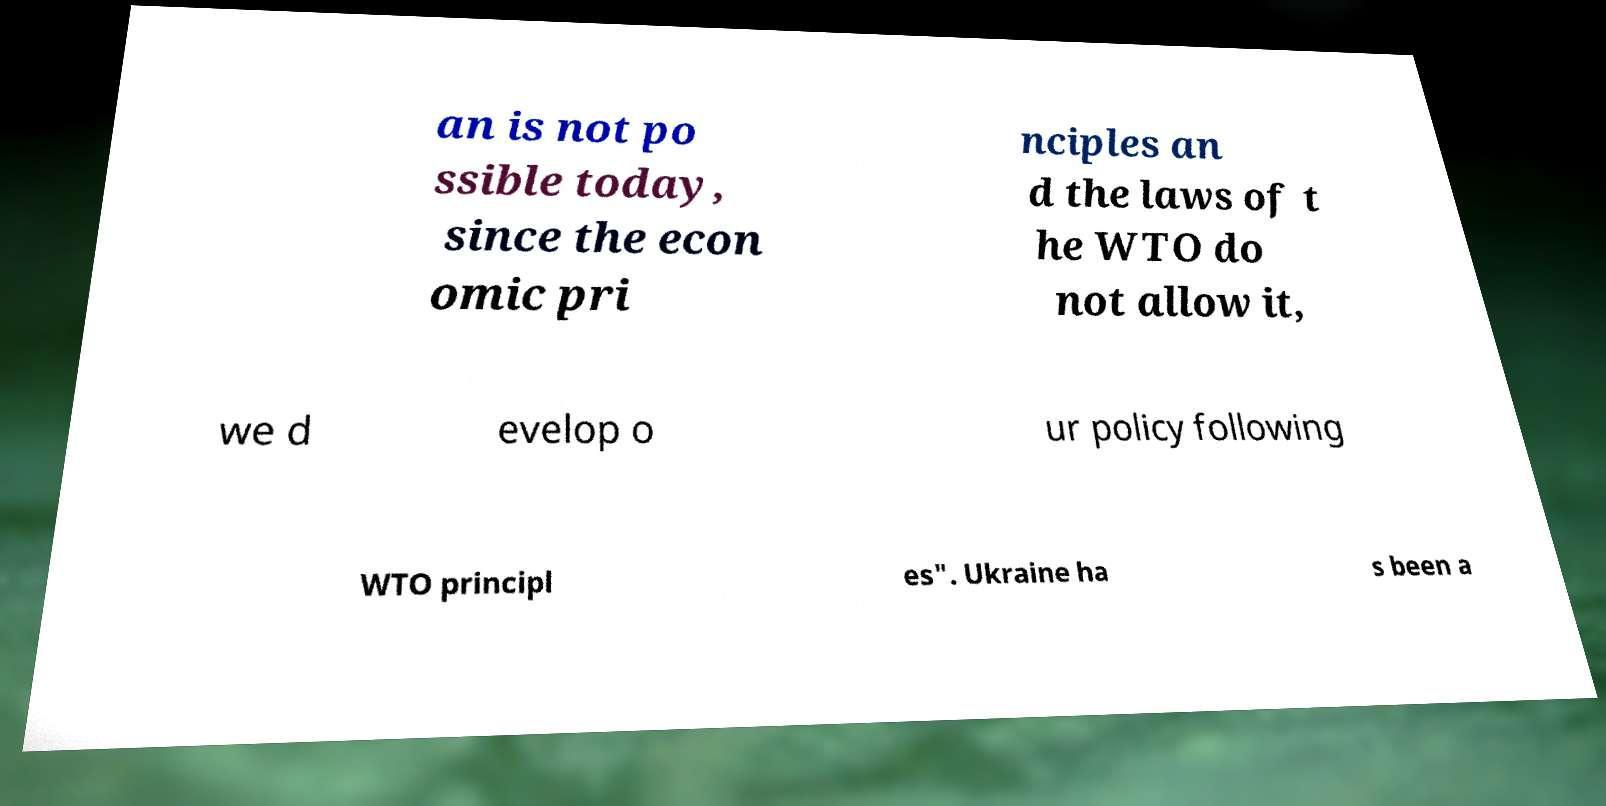Please identify and transcribe the text found in this image. an is not po ssible today, since the econ omic pri nciples an d the laws of t he WTO do not allow it, we d evelop o ur policy following WTO principl es". Ukraine ha s been a 